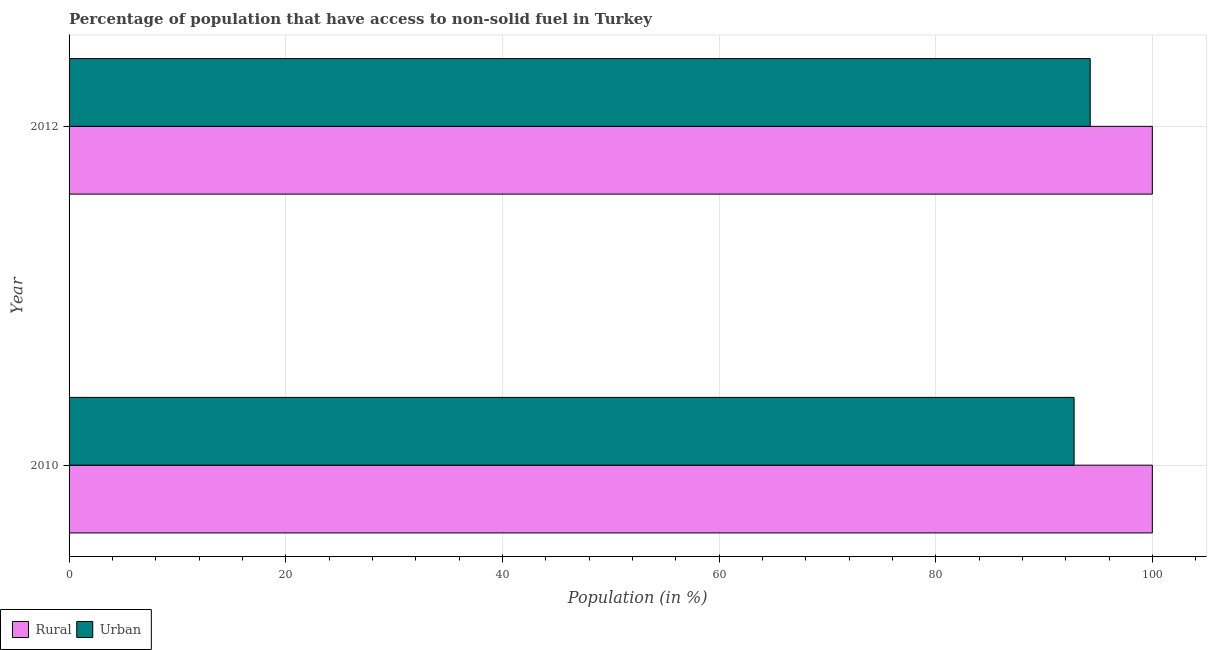How many different coloured bars are there?
Offer a very short reply. 2. How many groups of bars are there?
Ensure brevity in your answer.  2. Are the number of bars per tick equal to the number of legend labels?
Provide a short and direct response. Yes. In how many cases, is the number of bars for a given year not equal to the number of legend labels?
Provide a succinct answer. 0. What is the urban population in 2010?
Offer a very short reply. 92.78. Across all years, what is the maximum urban population?
Keep it short and to the point. 94.26. Across all years, what is the minimum urban population?
Your answer should be very brief. 92.78. In which year was the urban population maximum?
Give a very brief answer. 2012. In which year was the rural population minimum?
Your answer should be compact. 2010. What is the total rural population in the graph?
Provide a succinct answer. 200. What is the difference between the urban population in 2010 and that in 2012?
Keep it short and to the point. -1.49. What is the difference between the urban population in 2010 and the rural population in 2012?
Your answer should be very brief. -7.22. What is the average rural population per year?
Your answer should be compact. 100. In the year 2010, what is the difference between the urban population and rural population?
Make the answer very short. -7.22. In how many years, is the urban population greater than 24 %?
Your response must be concise. 2. Is the difference between the urban population in 2010 and 2012 greater than the difference between the rural population in 2010 and 2012?
Offer a terse response. No. What does the 2nd bar from the top in 2010 represents?
Offer a very short reply. Rural. What does the 1st bar from the bottom in 2010 represents?
Make the answer very short. Rural. How many years are there in the graph?
Provide a succinct answer. 2. Are the values on the major ticks of X-axis written in scientific E-notation?
Give a very brief answer. No. Does the graph contain grids?
Your answer should be very brief. Yes. How many legend labels are there?
Your answer should be very brief. 2. How are the legend labels stacked?
Make the answer very short. Horizontal. What is the title of the graph?
Your answer should be compact. Percentage of population that have access to non-solid fuel in Turkey. What is the label or title of the Y-axis?
Provide a succinct answer. Year. What is the Population (in %) in Rural in 2010?
Provide a succinct answer. 100. What is the Population (in %) of Urban in 2010?
Offer a terse response. 92.78. What is the Population (in %) of Urban in 2012?
Provide a succinct answer. 94.26. Across all years, what is the maximum Population (in %) in Rural?
Provide a succinct answer. 100. Across all years, what is the maximum Population (in %) of Urban?
Offer a very short reply. 94.26. Across all years, what is the minimum Population (in %) of Urban?
Provide a short and direct response. 92.78. What is the total Population (in %) in Urban in the graph?
Provide a short and direct response. 187.04. What is the difference between the Population (in %) in Rural in 2010 and that in 2012?
Keep it short and to the point. 0. What is the difference between the Population (in %) in Urban in 2010 and that in 2012?
Make the answer very short. -1.49. What is the difference between the Population (in %) of Rural in 2010 and the Population (in %) of Urban in 2012?
Provide a short and direct response. 5.74. What is the average Population (in %) in Urban per year?
Offer a very short reply. 93.52. In the year 2010, what is the difference between the Population (in %) of Rural and Population (in %) of Urban?
Provide a short and direct response. 7.22. In the year 2012, what is the difference between the Population (in %) of Rural and Population (in %) of Urban?
Provide a short and direct response. 5.74. What is the ratio of the Population (in %) in Rural in 2010 to that in 2012?
Ensure brevity in your answer.  1. What is the ratio of the Population (in %) of Urban in 2010 to that in 2012?
Your answer should be compact. 0.98. What is the difference between the highest and the second highest Population (in %) in Urban?
Keep it short and to the point. 1.49. What is the difference between the highest and the lowest Population (in %) of Urban?
Ensure brevity in your answer.  1.49. 